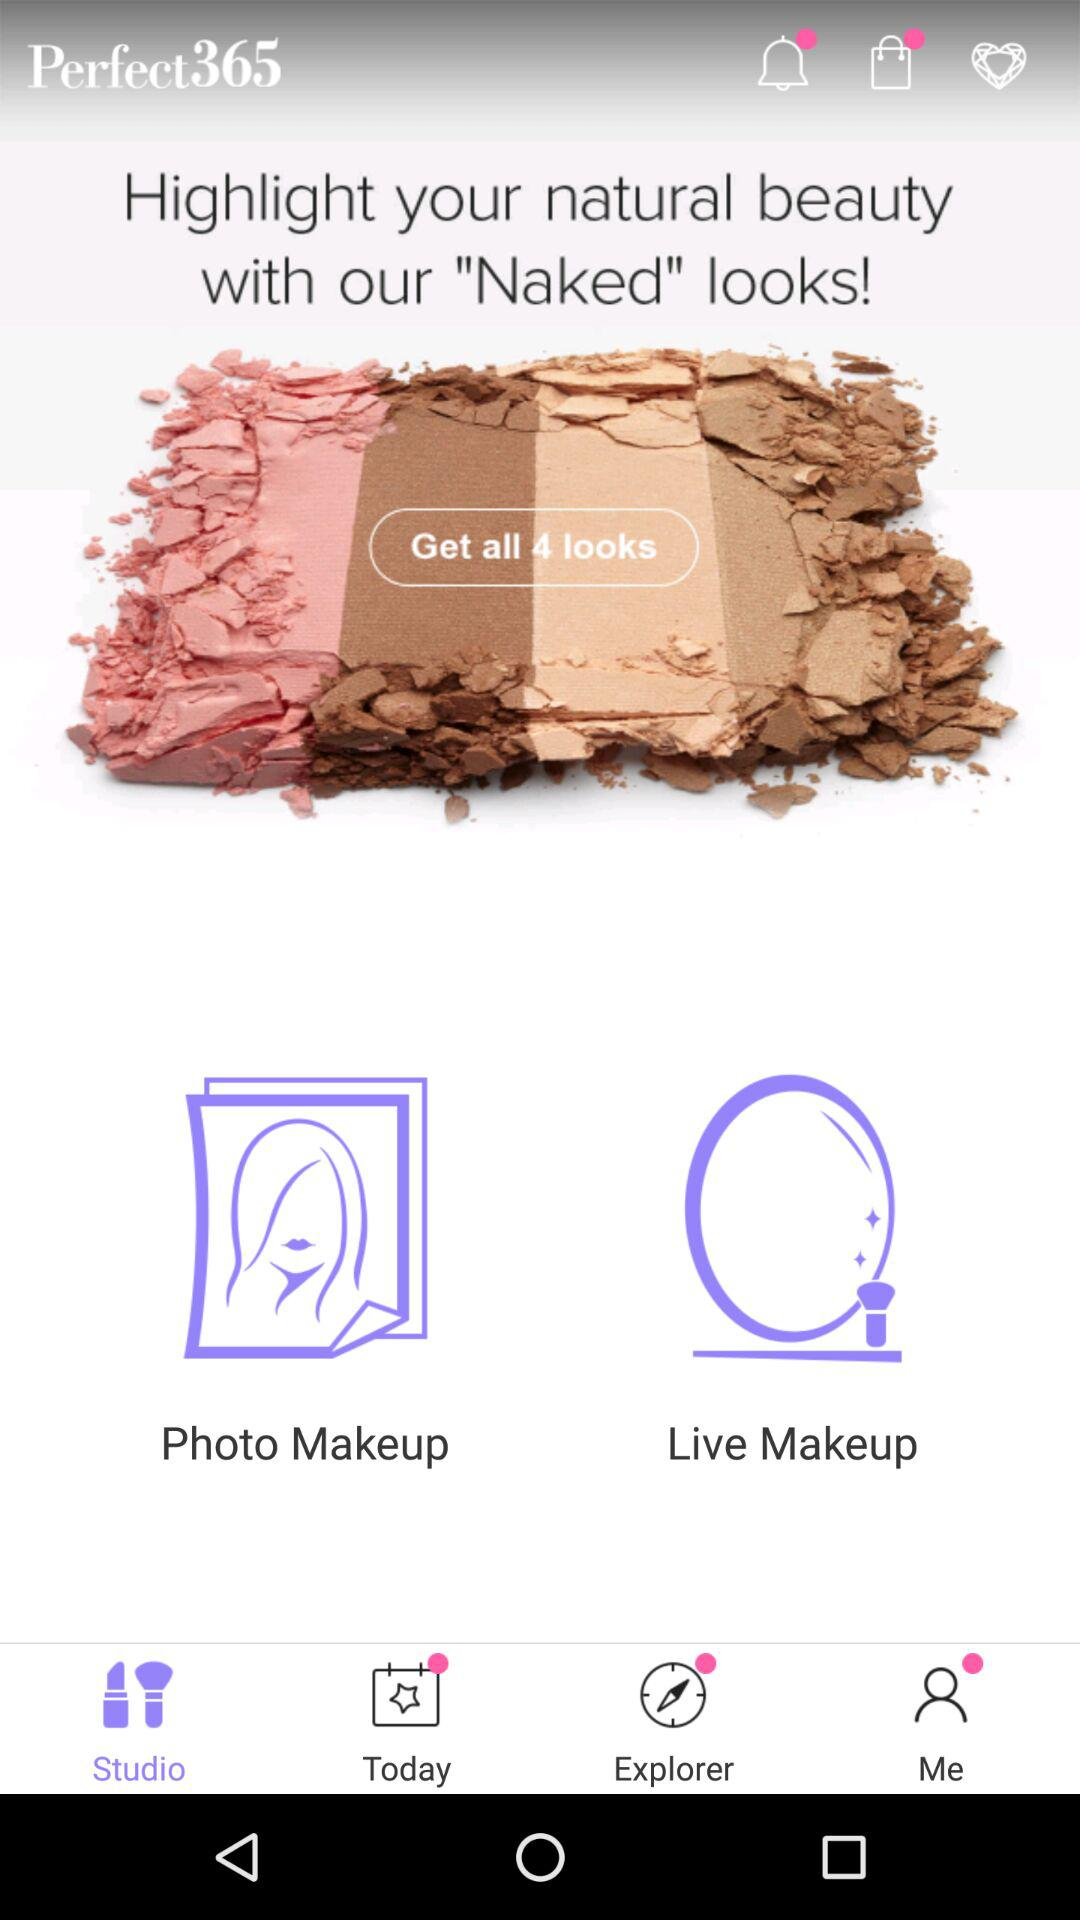Which tab is selected? The selected tab is "Studio". 